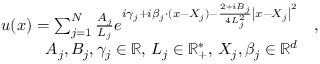<formula> <loc_0><loc_0><loc_500><loc_500>\begin{array} { r l } { u ( x ) = \sum _ { j = 1 } ^ { N } \frac { A _ { j } } { L _ { j } } e ^ { i \gamma _ { j } + i \beta _ { j } \cdot ( x - X _ { j } ) - \frac { 2 + i B _ { j } } { 4 L _ { j } ^ { 2 } } \left | x - X _ { j } \right | ^ { 2 } } } & { , } \\ { A _ { j } , B _ { j } , \gamma _ { j } \in \mathbb { R } , \, L _ { j } \in \mathbb { R } _ { + } ^ { * } , \, X _ { j } , \beta _ { j } \in \mathbb { R } ^ { d } } \end{array}</formula> 